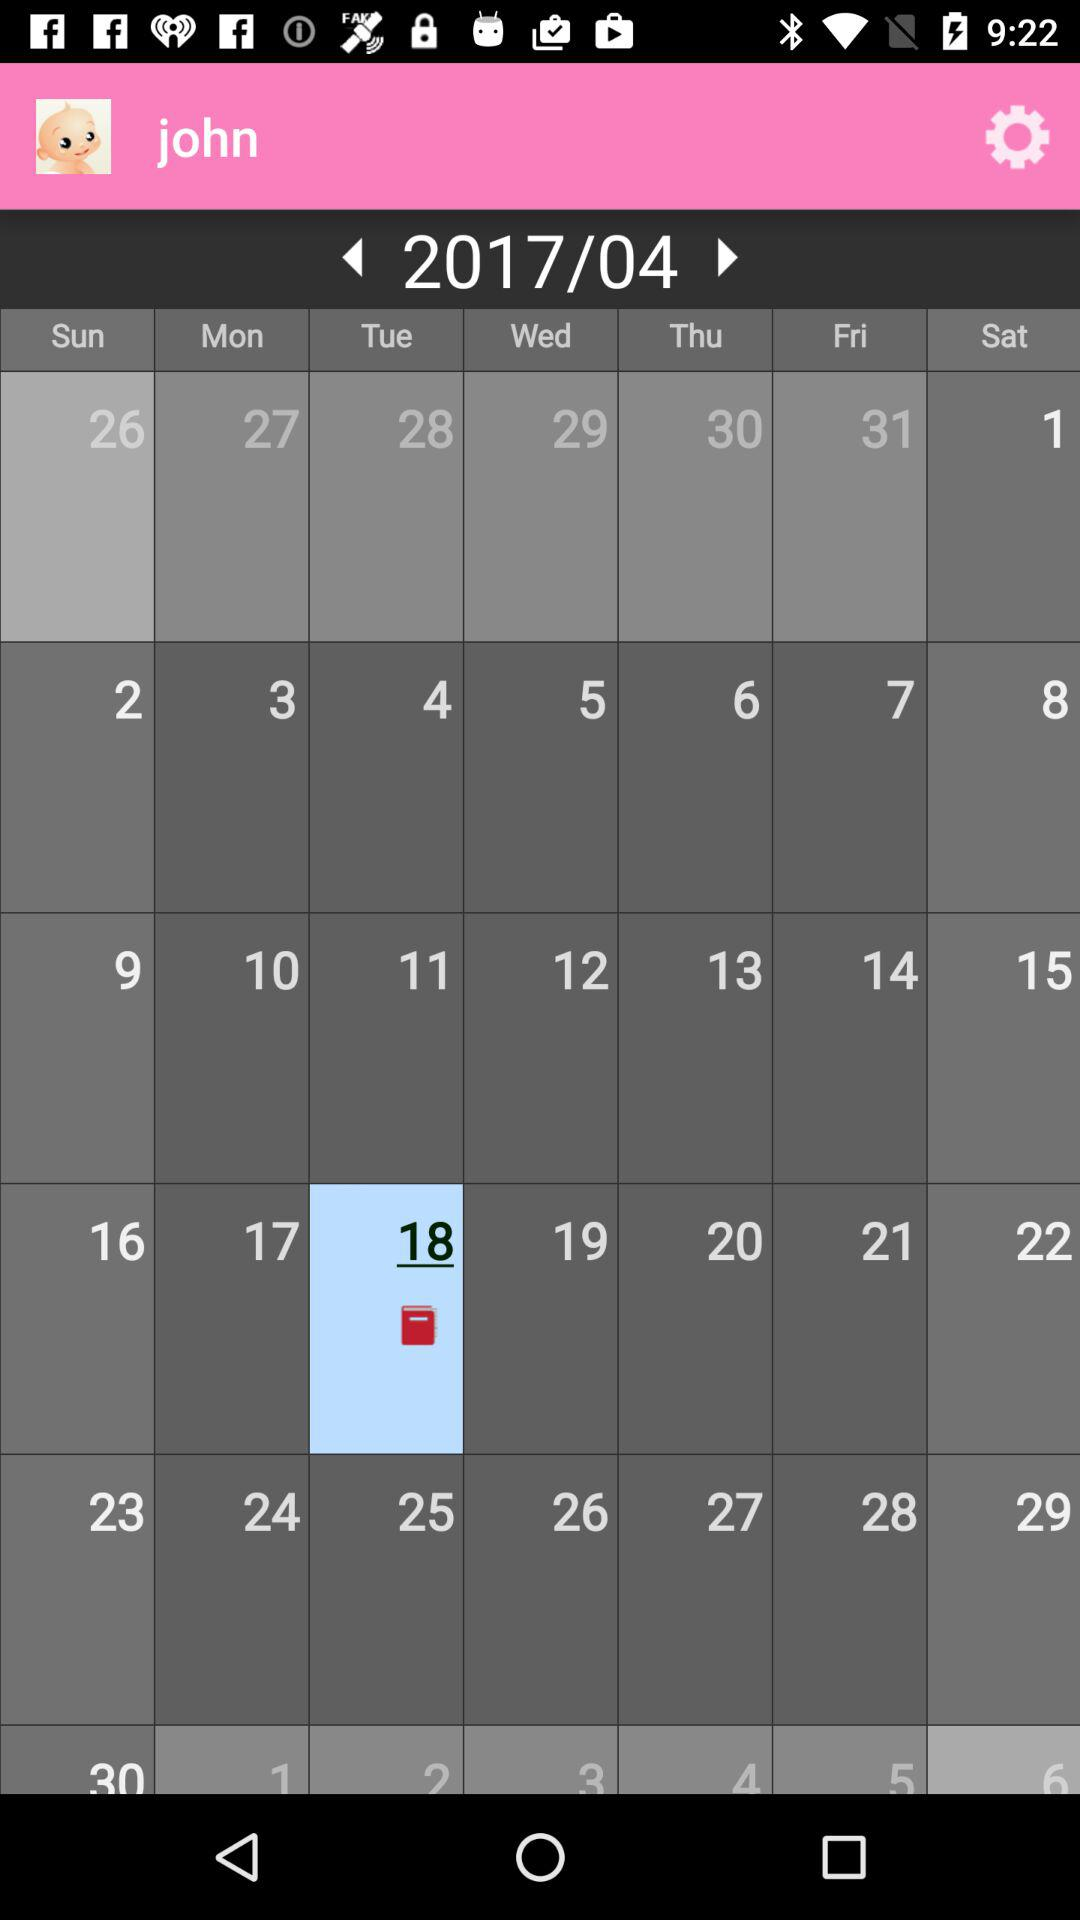What is the name of the user? The name of the user is John. 